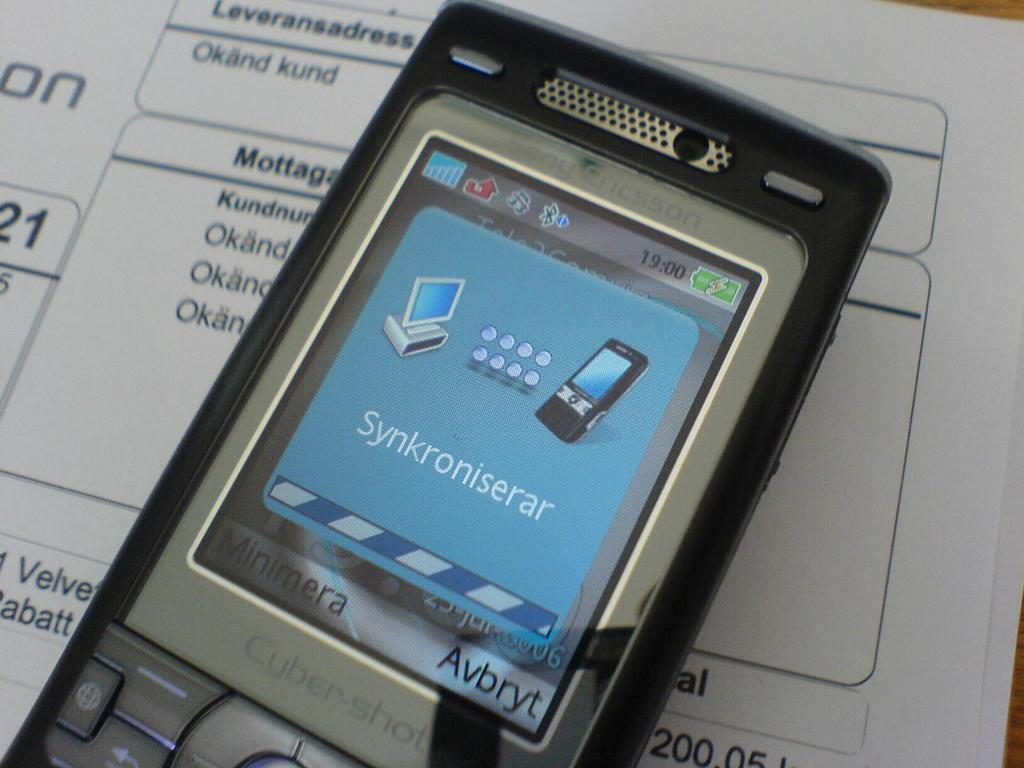<image>
Relay a brief, clear account of the picture shown. The phone pictured is a cybershot mobile phone. 